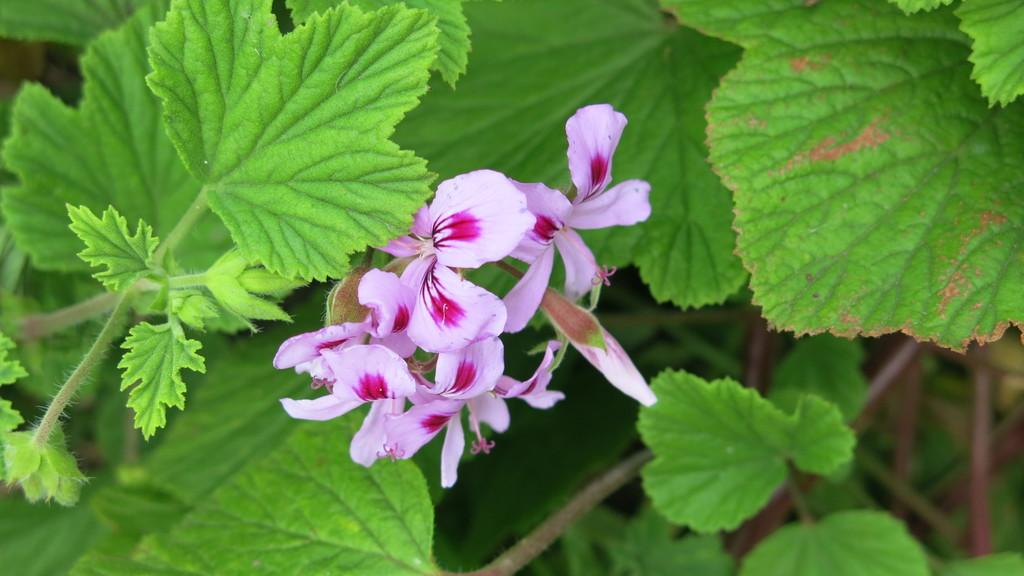What type of plants can be seen in the image? There are flowers, stems, and leaves in the image. Can you describe the different parts of the plants in the image? Yes, the image shows flowers, stems, and leaves. What might be the purpose of the stems in the image? The stems in the image provide support for the flowers and leaves. What type of watch can be seen on the sea in the image? There is no watch or sea present in the image; it features plants with flowers, stems, and leaves. 